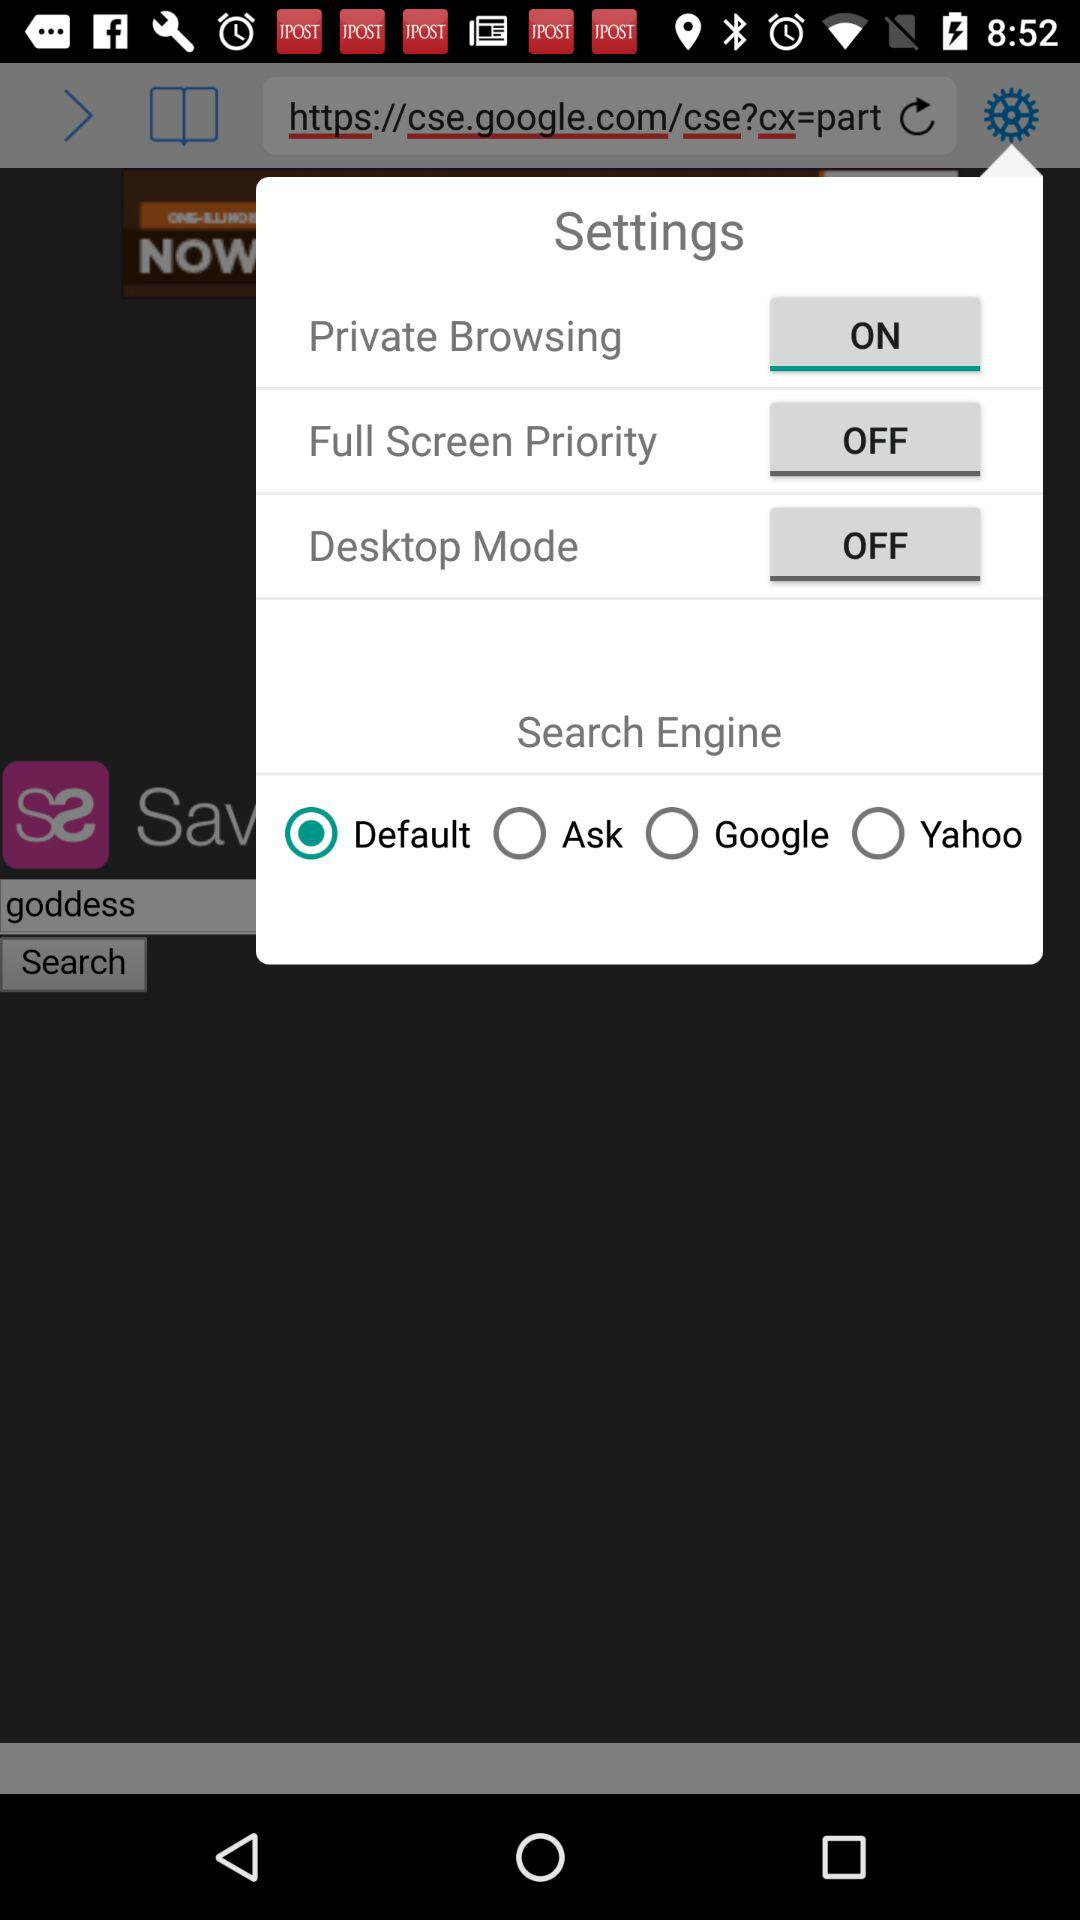What is the status of "Desktop mode"? The status is "off". 